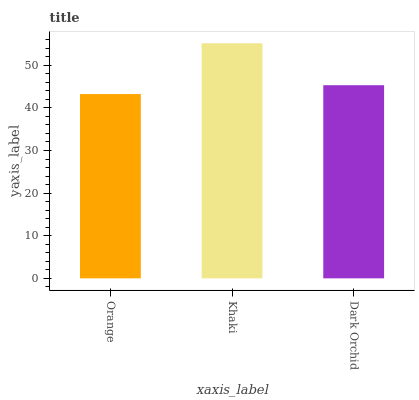Is Orange the minimum?
Answer yes or no. Yes. Is Khaki the maximum?
Answer yes or no. Yes. Is Dark Orchid the minimum?
Answer yes or no. No. Is Dark Orchid the maximum?
Answer yes or no. No. Is Khaki greater than Dark Orchid?
Answer yes or no. Yes. Is Dark Orchid less than Khaki?
Answer yes or no. Yes. Is Dark Orchid greater than Khaki?
Answer yes or no. No. Is Khaki less than Dark Orchid?
Answer yes or no. No. Is Dark Orchid the high median?
Answer yes or no. Yes. Is Dark Orchid the low median?
Answer yes or no. Yes. Is Orange the high median?
Answer yes or no. No. Is Khaki the low median?
Answer yes or no. No. 